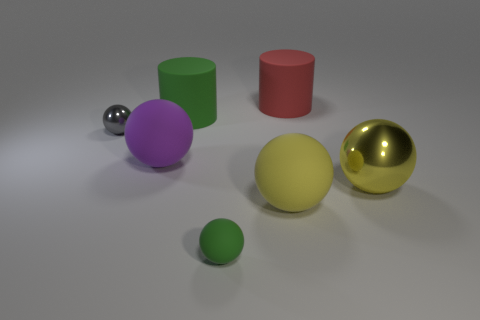Subtract all big rubber spheres. How many spheres are left? 3 Subtract all red cylinders. How many cylinders are left? 1 Add 1 large red cylinders. How many objects exist? 8 Subtract all large red matte blocks. Subtract all large red cylinders. How many objects are left? 6 Add 6 large yellow rubber things. How many large yellow rubber things are left? 7 Add 6 large rubber cylinders. How many large rubber cylinders exist? 8 Subtract 0 brown spheres. How many objects are left? 7 Subtract all cylinders. How many objects are left? 5 Subtract 2 cylinders. How many cylinders are left? 0 Subtract all yellow cylinders. Subtract all cyan blocks. How many cylinders are left? 2 